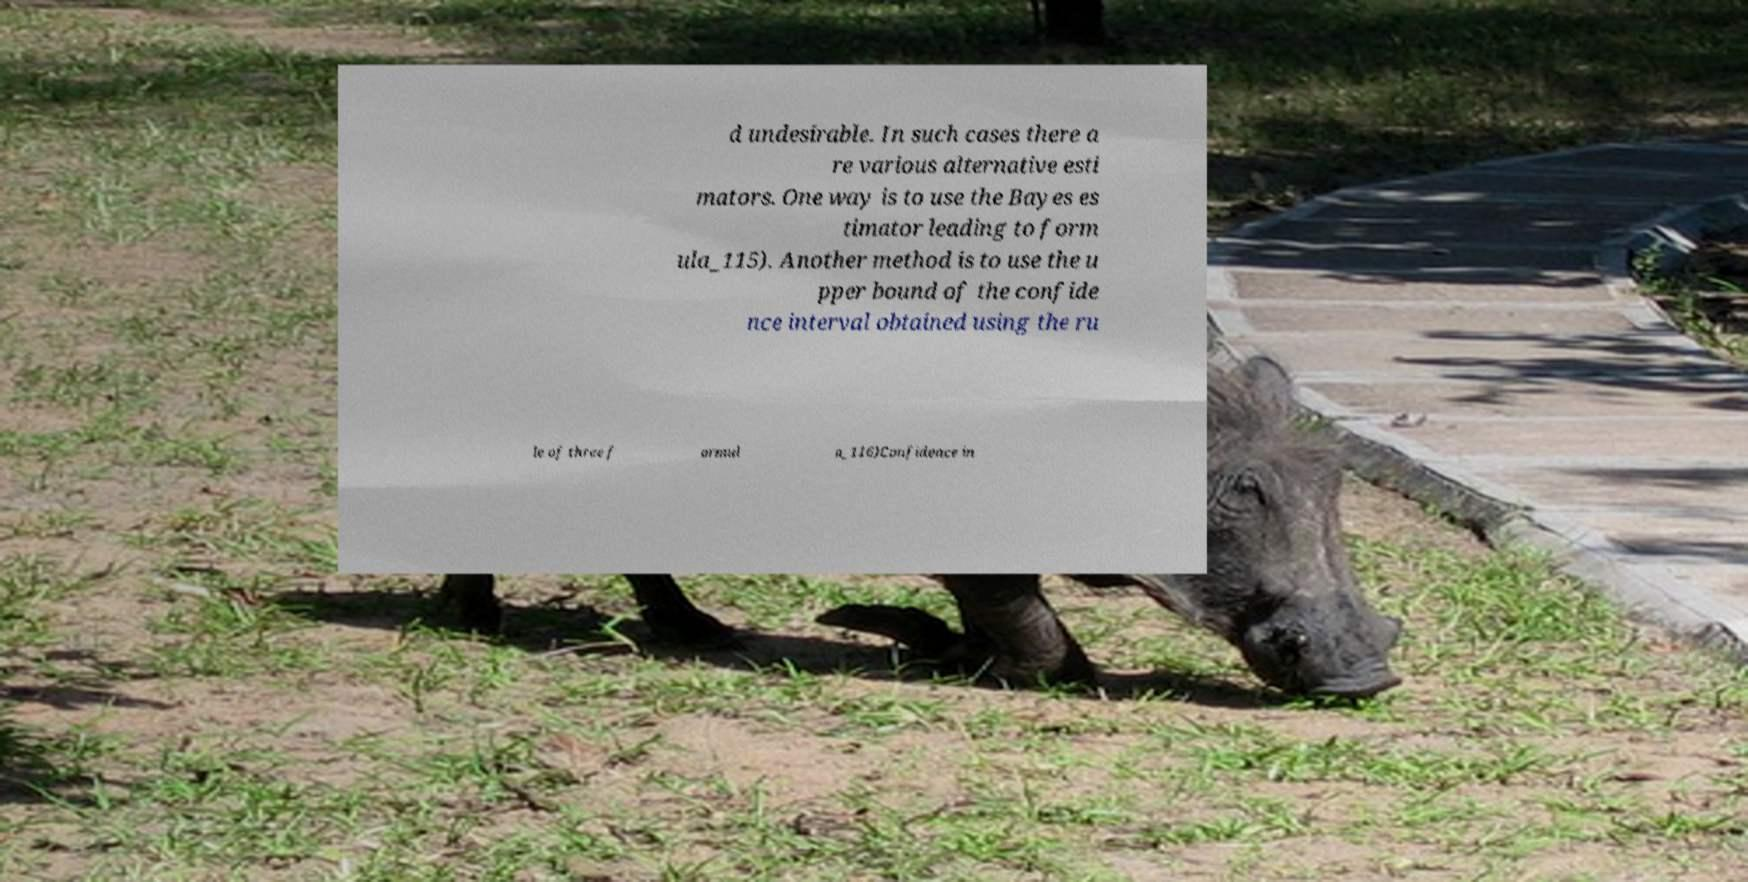For documentation purposes, I need the text within this image transcribed. Could you provide that? d undesirable. In such cases there a re various alternative esti mators. One way is to use the Bayes es timator leading to form ula_115). Another method is to use the u pper bound of the confide nce interval obtained using the ru le of three f ormul a_116)Confidence in 